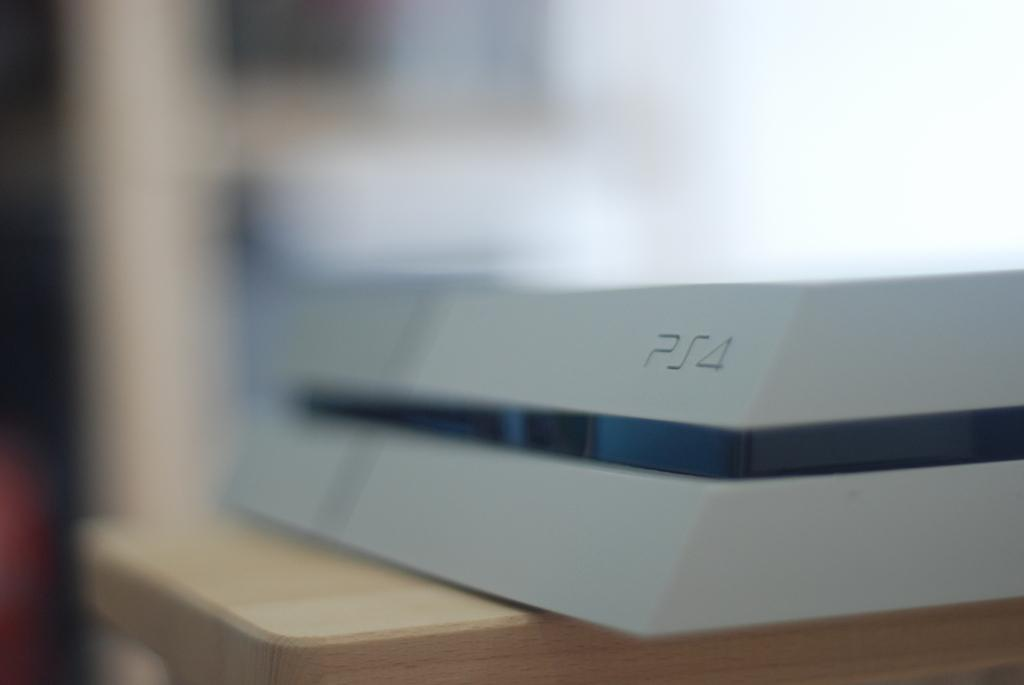Provide a one-sentence caption for the provided image. The blue and white box contains a PS4. 